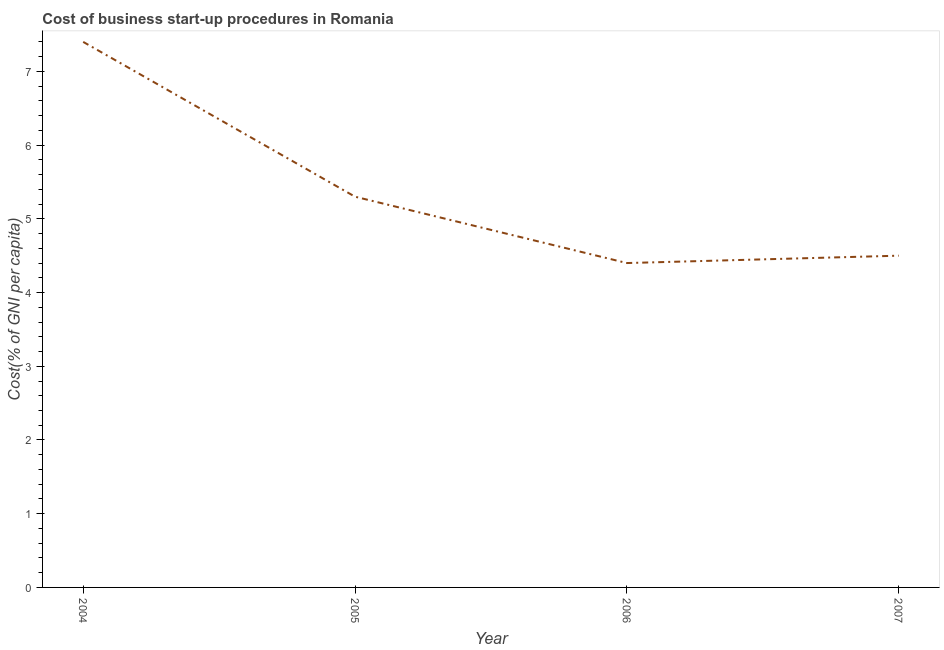Across all years, what is the maximum cost of business startup procedures?
Provide a succinct answer. 7.4. In which year was the cost of business startup procedures maximum?
Provide a succinct answer. 2004. In which year was the cost of business startup procedures minimum?
Your response must be concise. 2006. What is the sum of the cost of business startup procedures?
Keep it short and to the point. 21.6. What is the difference between the cost of business startup procedures in 2004 and 2007?
Keep it short and to the point. 2.9. What is the average cost of business startup procedures per year?
Ensure brevity in your answer.  5.4. What is the median cost of business startup procedures?
Keep it short and to the point. 4.9. What is the ratio of the cost of business startup procedures in 2004 to that in 2007?
Provide a short and direct response. 1.64. Is the cost of business startup procedures in 2004 less than that in 2007?
Your answer should be very brief. No. What is the difference between the highest and the second highest cost of business startup procedures?
Your response must be concise. 2.1. Does the cost of business startup procedures monotonically increase over the years?
Provide a short and direct response. No. How many lines are there?
Offer a terse response. 1. How many years are there in the graph?
Your answer should be very brief. 4. Are the values on the major ticks of Y-axis written in scientific E-notation?
Give a very brief answer. No. Does the graph contain any zero values?
Your response must be concise. No. What is the title of the graph?
Your answer should be compact. Cost of business start-up procedures in Romania. What is the label or title of the Y-axis?
Your answer should be compact. Cost(% of GNI per capita). What is the Cost(% of GNI per capita) of 2006?
Offer a very short reply. 4.4. What is the difference between the Cost(% of GNI per capita) in 2004 and 2005?
Provide a short and direct response. 2.1. What is the difference between the Cost(% of GNI per capita) in 2004 and 2006?
Ensure brevity in your answer.  3. What is the difference between the Cost(% of GNI per capita) in 2004 and 2007?
Offer a very short reply. 2.9. What is the difference between the Cost(% of GNI per capita) in 2005 and 2006?
Your answer should be very brief. 0.9. What is the difference between the Cost(% of GNI per capita) in 2005 and 2007?
Give a very brief answer. 0.8. What is the ratio of the Cost(% of GNI per capita) in 2004 to that in 2005?
Provide a short and direct response. 1.4. What is the ratio of the Cost(% of GNI per capita) in 2004 to that in 2006?
Ensure brevity in your answer.  1.68. What is the ratio of the Cost(% of GNI per capita) in 2004 to that in 2007?
Make the answer very short. 1.64. What is the ratio of the Cost(% of GNI per capita) in 2005 to that in 2006?
Offer a terse response. 1.21. What is the ratio of the Cost(% of GNI per capita) in 2005 to that in 2007?
Ensure brevity in your answer.  1.18. What is the ratio of the Cost(% of GNI per capita) in 2006 to that in 2007?
Your answer should be very brief. 0.98. 